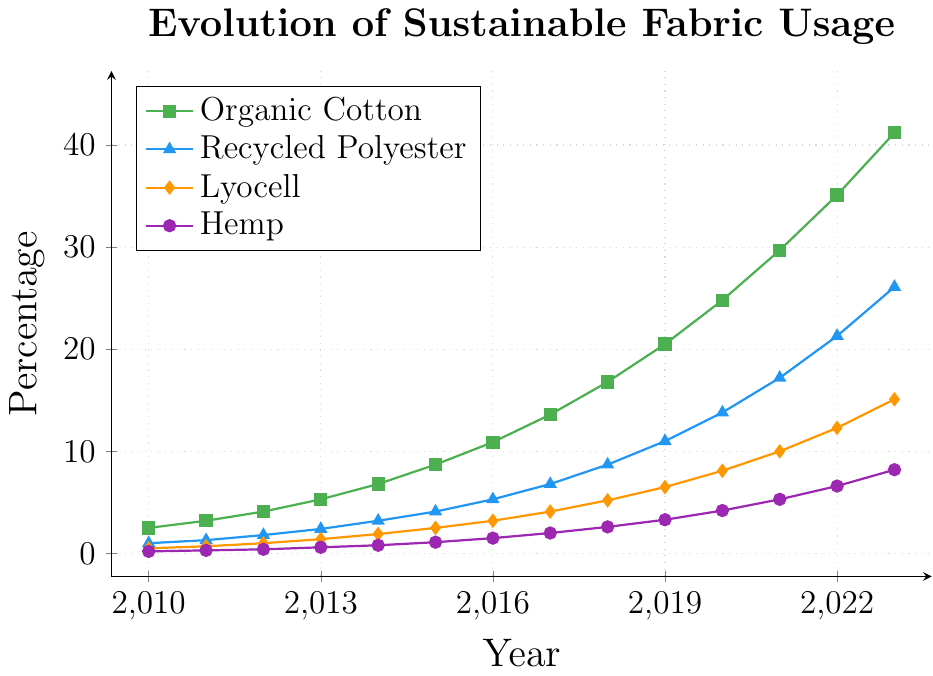What is the trend of Organic Cotton usage over the years? Organic Cotton usage shows a consistent and significant increase from 2.5% in 2010 to 41.2% in 2023. This indicates a strong upward trend in the adoption of Organic Cotton.
Answer: Upward trend Which year did Recycled Polyester surpass 20% usage? By examining the vertical positions of the points representing Recycled Polyester, we can see that in 2022, Recycled Polyester usage reached 21.3%, surpassing 20% for the first time.
Answer: 2022 Which fabric had the least percentage usage in 2010? In 2010, we compare the vertical positions of the points for each fabric. Hemp, at 0.2%, was the least used fabric in that year.
Answer: Hemp By how much did Lyocell usage increase from 2015 to 2020? Lyocell usage in 2015 was 2.5% and increased to 8.1% in 2020. The increase can be calculated as 8.1% - 2.5% = 5.6%.
Answer: 5.6% How does the usage of Hemp in 2023 compare to that of Lyocell in 2016? In 2023, Hemp usage is 8.2%, whereas, in 2016, Lyocell usage was 3.2%. Thus, Hemp usage in 2023 is higher.
Answer: Higher What year did Organic Cotton surpass Hemp in usage, and by how much percentage? In 2010, Organic Cotton usage was 2.5% and Hemp was 0.2%. The difference is 2.5% - 0.2% = 2.3%. Organic Cotton always remained higher, so the year is 2010.
Answer: 2010, 2.3% In which year did all four fabrics see an increase in usage? By looking at the continuous upward trend for all the fabrics, every year from 2010 to 2023 shows an increase in the usage of all four fabrics.
Answer: Every year from 2010 to 2023 What's the average usage percentage of Recycled Polyester from 2010 to 2023? To find the average, we add the percentages for Recycled Polyester from 2010 to 2023 and divide by the number of years: (1.0 + 1.3 + 1.8 + 2.4 + 3.2 + 4.1 + 5.3 + 6.8 + 8.7 + 11.0 + 13.8 + 17.2 + 21.3 + 26.1) / 14 = 8.5%.
Answer: 8.5% Compare the usage trends of Organic Cotton and Recycled Polyester between 2015 and 2023. Both Organic Cotton and Recycled Polyester show upward trends. Organic Cotton increased from 8.7% to 41.2%, while Recycled Polyester rose from 4.1% to 26.1%. Both show significant growth, but Organic Cotton grew more.
Answer: Both increased, Organic Cotton more 